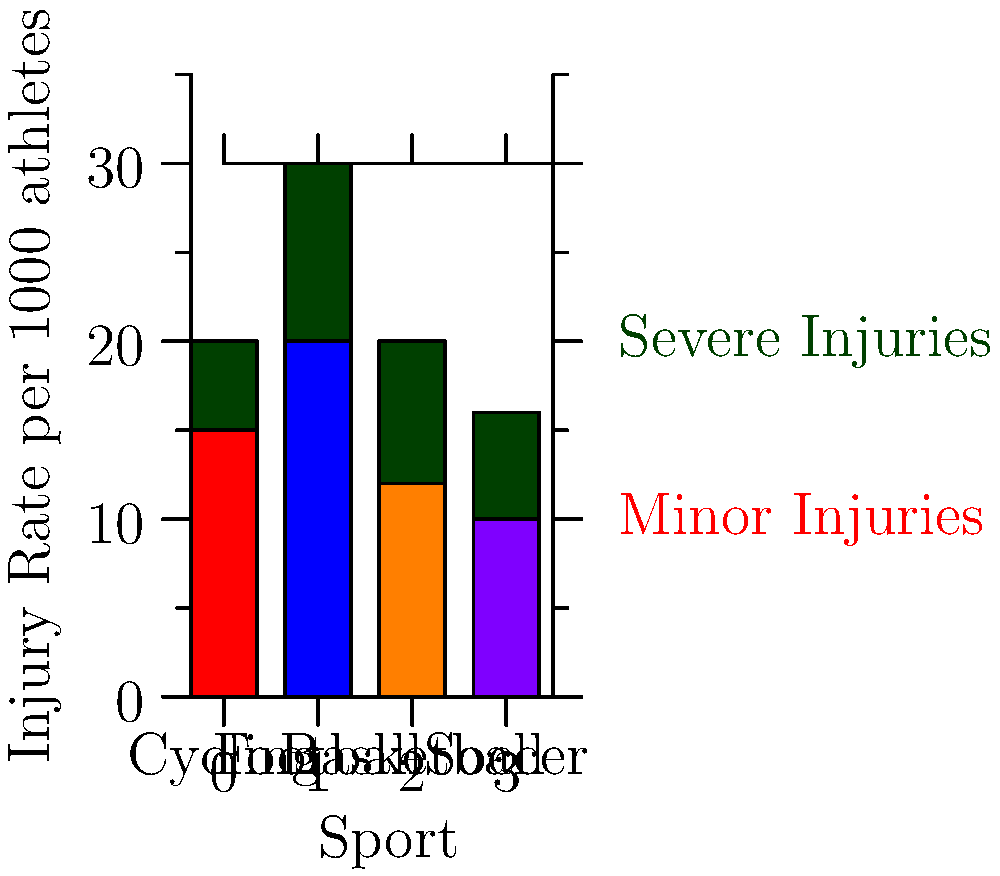Based on the stacked bar chart comparing injury rates in different sports, which sport has the highest rate of severe injuries per 1000 athletes? To determine which sport has the highest rate of severe injuries, we need to examine the dark green portion of each bar, which represents severe injuries:

1. Cycling: The dark green portion is approximately 5 units high.
2. Football: The dark green portion is approximately 10 units high.
3. Basketball: The dark green portion is approximately 8 units high.
4. Soccer: The dark green portion is approximately 6 units high.

Comparing these values, we can see that football has the highest rate of severe injuries at about 10 per 1000 athletes.

It's worth noting that while cycling doesn't have the highest rate of severe injuries, it does have a relatively high rate of minor injuries (represented by the red portion of the bar). This could be an interesting point for a sports journalist with a slight bias against the cycling industry to consider in their reporting.
Answer: Football 